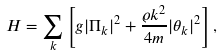Convert formula to latex. <formula><loc_0><loc_0><loc_500><loc_500>H = \sum _ { k } \left [ g | \Pi _ { k } | ^ { 2 } + \frac { \varrho { k } ^ { 2 } } { 4 m } | \theta _ { k } | ^ { 2 } \right ] ,</formula> 